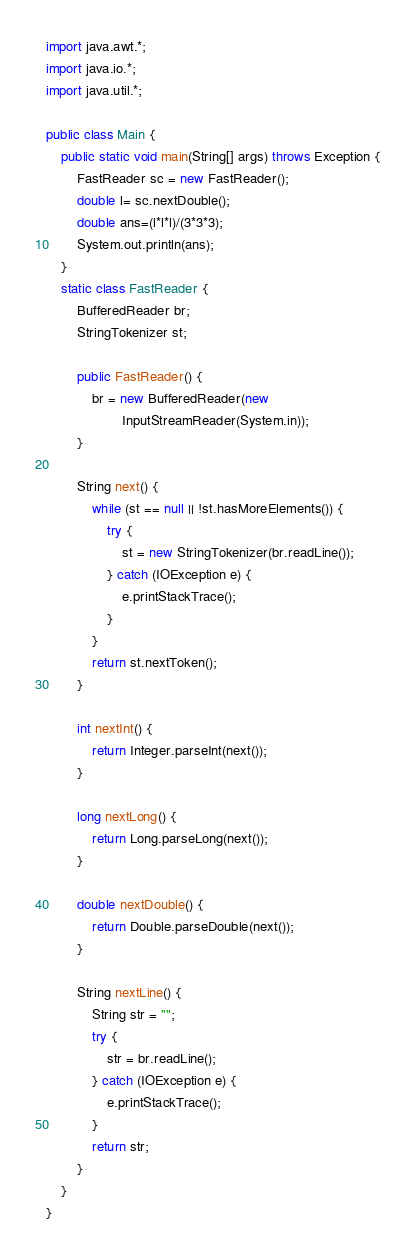Convert code to text. <code><loc_0><loc_0><loc_500><loc_500><_Java_>import java.awt.*;
import java.io.*;
import java.util.*;

public class Main {
    public static void main(String[] args) throws Exception {
        FastReader sc = new FastReader();
        double l= sc.nextDouble();
        double ans=(l*l*l)/(3*3*3);
        System.out.println(ans);
    }
    static class FastReader {
        BufferedReader br;
        StringTokenizer st;

        public FastReader() {
            br = new BufferedReader(new
                    InputStreamReader(System.in));
        }

        String next() {
            while (st == null || !st.hasMoreElements()) {
                try {
                    st = new StringTokenizer(br.readLine());
                } catch (IOException e) {
                    e.printStackTrace();
                }
            }
            return st.nextToken();
        }

        int nextInt() {
            return Integer.parseInt(next());
        }

        long nextLong() {
            return Long.parseLong(next());
        }

        double nextDouble() {
            return Double.parseDouble(next());
        }

        String nextLine() {
            String str = "";
            try {
                str = br.readLine();
            } catch (IOException e) {
                e.printStackTrace();
            }
            return str;
        }
    }
}</code> 